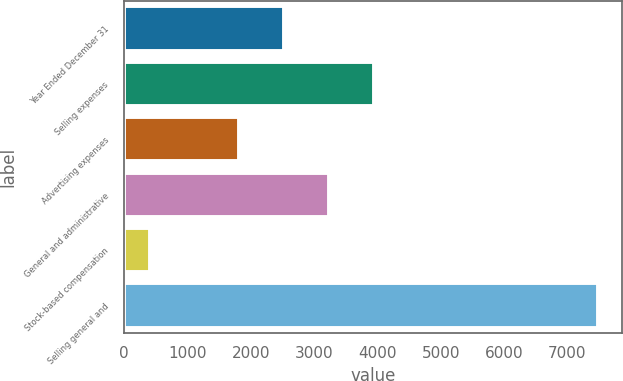Convert chart. <chart><loc_0><loc_0><loc_500><loc_500><bar_chart><fcel>Year Ended December 31<fcel>Selling expenses<fcel>Advertising expenses<fcel>General and administrative<fcel>Stock-based compensation<fcel>Selling general and<nl><fcel>2530.1<fcel>3946.3<fcel>1822<fcel>3238.2<fcel>407<fcel>7488<nl></chart> 